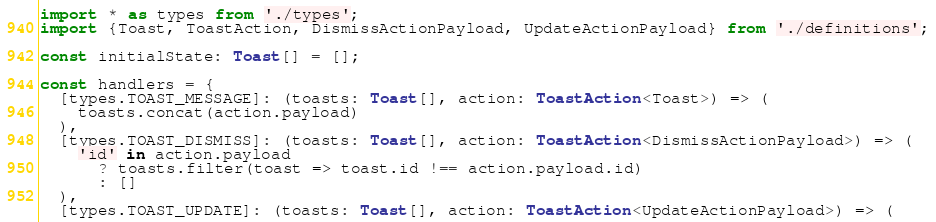Convert code to text. <code><loc_0><loc_0><loc_500><loc_500><_TypeScript_>import * as types from './types';
import {Toast, ToastAction, DismissActionPayload, UpdateActionPayload} from './definitions';

const initialState: Toast[] = [];

const handlers = {
  [types.TOAST_MESSAGE]: (toasts: Toast[], action: ToastAction<Toast>) => (
    toasts.concat(action.payload)
  ),
  [types.TOAST_DISMISS]: (toasts: Toast[], action: ToastAction<DismissActionPayload>) => (
    'id' in action.payload
      ? toasts.filter(toast => toast.id !== action.payload.id)
      : []
  ),
  [types.TOAST_UPDATE]: (toasts: Toast[], action: ToastAction<UpdateActionPayload>) => (</code> 